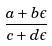Convert formula to latex. <formula><loc_0><loc_0><loc_500><loc_500>\frac { a + b \epsilon } { c + d \epsilon }</formula> 